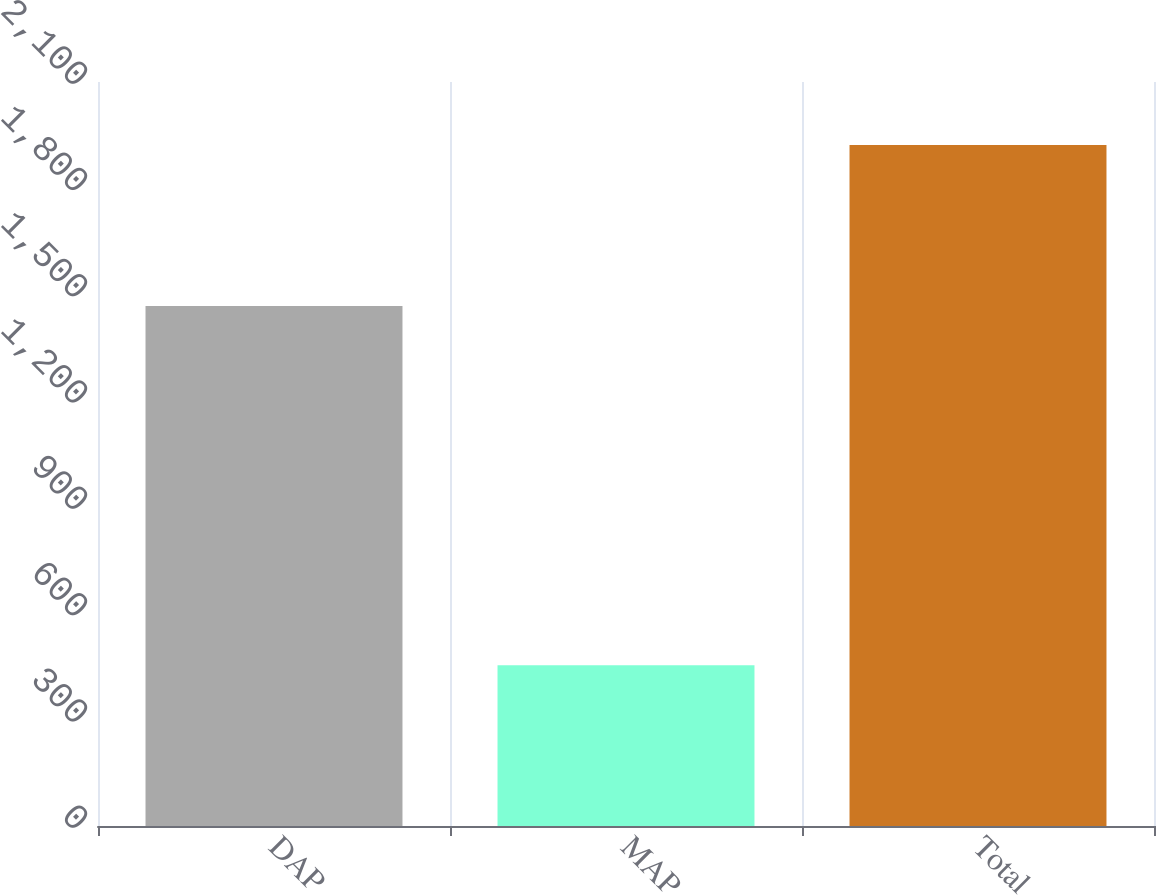Convert chart. <chart><loc_0><loc_0><loc_500><loc_500><bar_chart><fcel>DAP<fcel>MAP<fcel>Total<nl><fcel>1468<fcel>454<fcel>1922<nl></chart> 